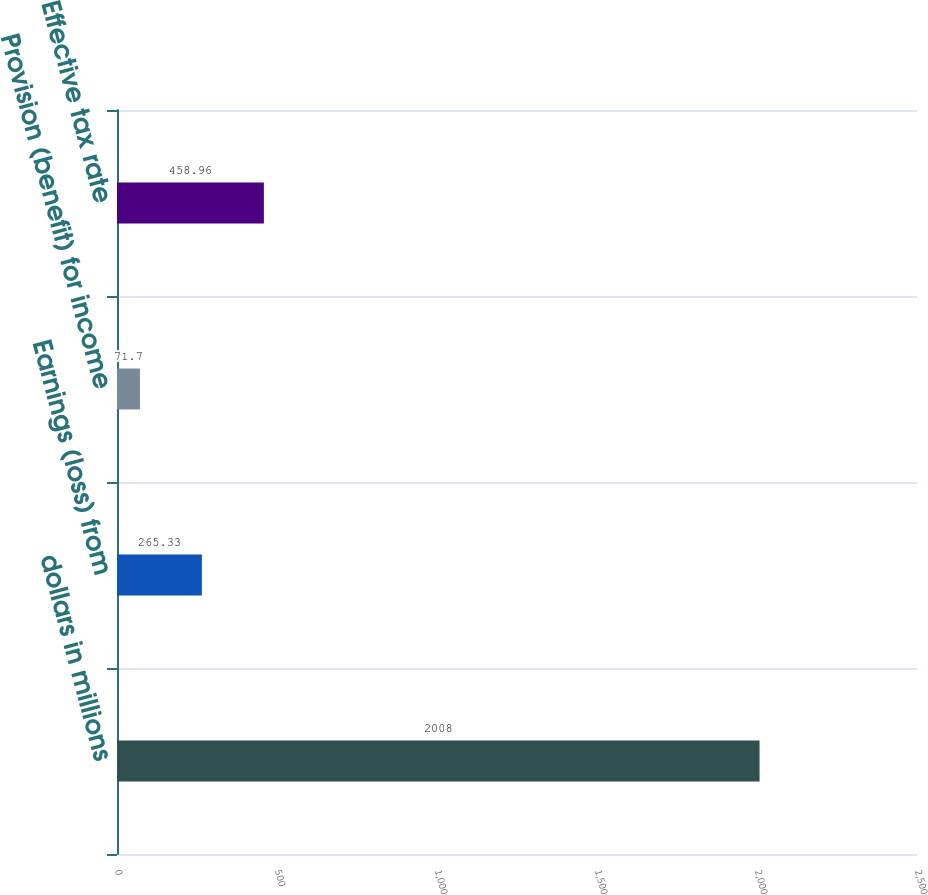Convert chart. <chart><loc_0><loc_0><loc_500><loc_500><bar_chart><fcel>dollars in millions<fcel>Earnings (loss) from<fcel>Provision (benefit) for income<fcel>Effective tax rate<nl><fcel>2008<fcel>265.33<fcel>71.7<fcel>458.96<nl></chart> 